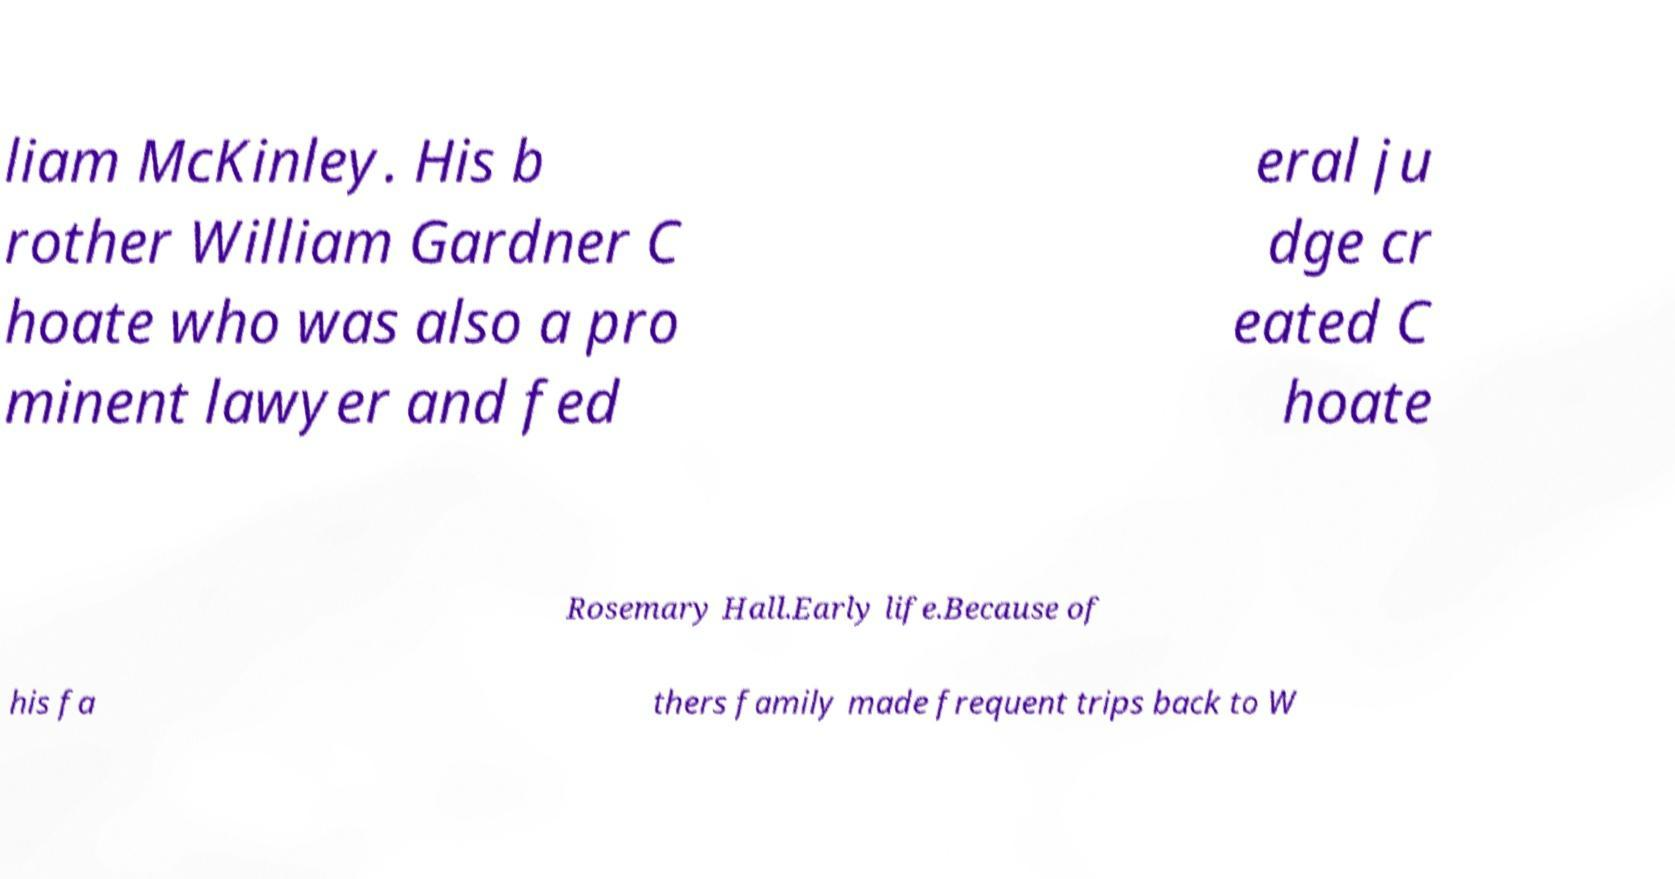Please read and relay the text visible in this image. What does it say? liam McKinley. His b rother William Gardner C hoate who was also a pro minent lawyer and fed eral ju dge cr eated C hoate Rosemary Hall.Early life.Because of his fa thers family made frequent trips back to W 